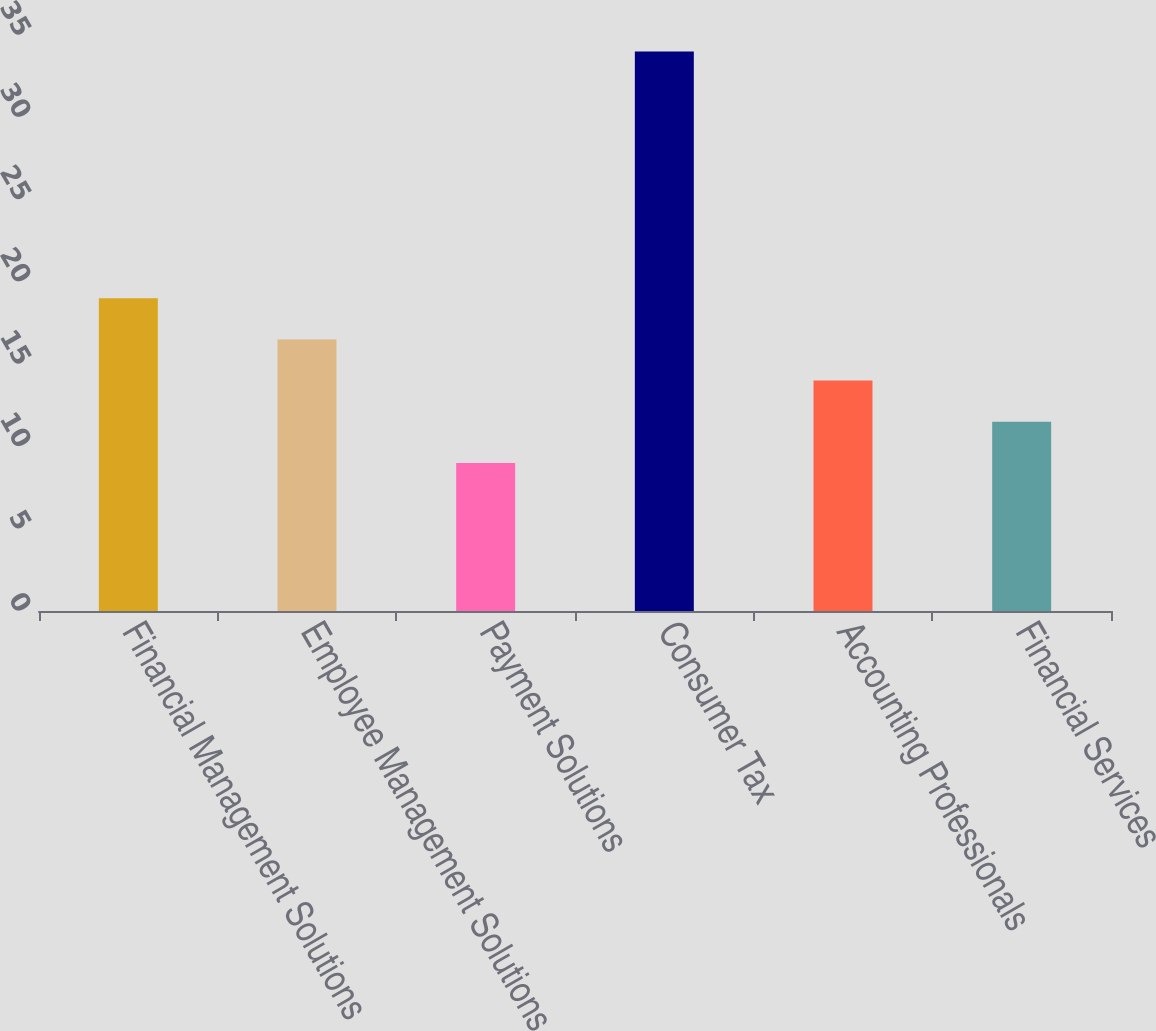<chart> <loc_0><loc_0><loc_500><loc_500><bar_chart><fcel>Financial Management Solutions<fcel>Employee Management Solutions<fcel>Payment Solutions<fcel>Consumer Tax<fcel>Accounting Professionals<fcel>Financial Services<nl><fcel>19<fcel>16.5<fcel>9<fcel>34<fcel>14<fcel>11.5<nl></chart> 